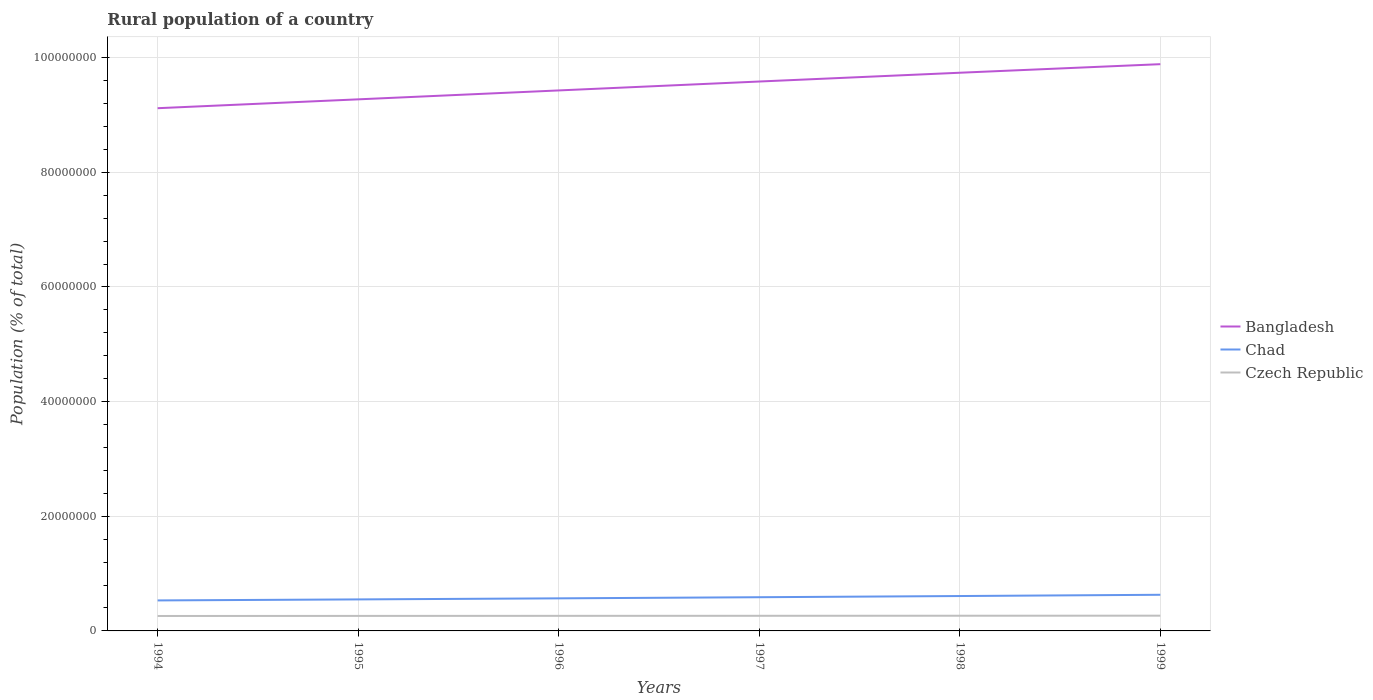Does the line corresponding to Czech Republic intersect with the line corresponding to Chad?
Keep it short and to the point. No. Is the number of lines equal to the number of legend labels?
Offer a very short reply. Yes. Across all years, what is the maximum rural population in Czech Republic?
Give a very brief answer. 2.61e+06. What is the total rural population in Bangladesh in the graph?
Give a very brief answer. -1.56e+06. What is the difference between the highest and the second highest rural population in Chad?
Your response must be concise. 9.84e+05. Is the rural population in Czech Republic strictly greater than the rural population in Bangladesh over the years?
Keep it short and to the point. Yes. How many lines are there?
Ensure brevity in your answer.  3. What is the difference between two consecutive major ticks on the Y-axis?
Offer a very short reply. 2.00e+07. Are the values on the major ticks of Y-axis written in scientific E-notation?
Make the answer very short. No. Does the graph contain any zero values?
Offer a very short reply. No. Does the graph contain grids?
Ensure brevity in your answer.  Yes. Where does the legend appear in the graph?
Offer a terse response. Center right. How are the legend labels stacked?
Keep it short and to the point. Vertical. What is the title of the graph?
Your answer should be very brief. Rural population of a country. What is the label or title of the Y-axis?
Keep it short and to the point. Population (% of total). What is the Population (% of total) in Bangladesh in 1994?
Offer a terse response. 9.12e+07. What is the Population (% of total) of Chad in 1994?
Your answer should be very brief. 5.32e+06. What is the Population (% of total) in Czech Republic in 1994?
Your answer should be compact. 2.61e+06. What is the Population (% of total) in Bangladesh in 1995?
Your response must be concise. 9.27e+07. What is the Population (% of total) of Chad in 1995?
Give a very brief answer. 5.50e+06. What is the Population (% of total) of Czech Republic in 1995?
Your answer should be very brief. 2.62e+06. What is the Population (% of total) in Bangladesh in 1996?
Ensure brevity in your answer.  9.43e+07. What is the Population (% of total) of Chad in 1996?
Offer a very short reply. 5.68e+06. What is the Population (% of total) of Czech Republic in 1996?
Provide a short and direct response. 2.63e+06. What is the Population (% of total) in Bangladesh in 1997?
Ensure brevity in your answer.  9.58e+07. What is the Population (% of total) of Chad in 1997?
Offer a very short reply. 5.88e+06. What is the Population (% of total) of Czech Republic in 1997?
Your answer should be very brief. 2.64e+06. What is the Population (% of total) of Bangladesh in 1998?
Keep it short and to the point. 9.74e+07. What is the Population (% of total) in Chad in 1998?
Provide a short and direct response. 6.09e+06. What is the Population (% of total) of Czech Republic in 1998?
Your response must be concise. 2.65e+06. What is the Population (% of total) in Bangladesh in 1999?
Your answer should be very brief. 9.89e+07. What is the Population (% of total) in Chad in 1999?
Give a very brief answer. 6.31e+06. What is the Population (% of total) in Czech Republic in 1999?
Your answer should be very brief. 2.66e+06. Across all years, what is the maximum Population (% of total) in Bangladesh?
Your response must be concise. 9.89e+07. Across all years, what is the maximum Population (% of total) of Chad?
Make the answer very short. 6.31e+06. Across all years, what is the maximum Population (% of total) in Czech Republic?
Your response must be concise. 2.66e+06. Across all years, what is the minimum Population (% of total) in Bangladesh?
Your answer should be compact. 9.12e+07. Across all years, what is the minimum Population (% of total) in Chad?
Offer a terse response. 5.32e+06. Across all years, what is the minimum Population (% of total) in Czech Republic?
Provide a short and direct response. 2.61e+06. What is the total Population (% of total) in Bangladesh in the graph?
Make the answer very short. 5.70e+08. What is the total Population (% of total) in Chad in the graph?
Offer a terse response. 3.48e+07. What is the total Population (% of total) in Czech Republic in the graph?
Your answer should be very brief. 1.58e+07. What is the difference between the Population (% of total) in Bangladesh in 1994 and that in 1995?
Offer a terse response. -1.55e+06. What is the difference between the Population (% of total) of Chad in 1994 and that in 1995?
Offer a very short reply. -1.77e+05. What is the difference between the Population (% of total) of Czech Republic in 1994 and that in 1995?
Offer a very short reply. -1.17e+04. What is the difference between the Population (% of total) in Bangladesh in 1994 and that in 1996?
Your answer should be compact. -3.10e+06. What is the difference between the Population (% of total) in Chad in 1994 and that in 1996?
Your response must be concise. -3.64e+05. What is the difference between the Population (% of total) in Czech Republic in 1994 and that in 1996?
Your answer should be very brief. -2.21e+04. What is the difference between the Population (% of total) of Bangladesh in 1994 and that in 1997?
Your answer should be compact. -4.65e+06. What is the difference between the Population (% of total) in Chad in 1994 and that in 1997?
Provide a short and direct response. -5.59e+05. What is the difference between the Population (% of total) of Czech Republic in 1994 and that in 1997?
Your answer should be compact. -3.28e+04. What is the difference between the Population (% of total) of Bangladesh in 1994 and that in 1998?
Ensure brevity in your answer.  -6.19e+06. What is the difference between the Population (% of total) of Chad in 1994 and that in 1998?
Keep it short and to the point. -7.65e+05. What is the difference between the Population (% of total) in Czech Republic in 1994 and that in 1998?
Ensure brevity in your answer.  -4.37e+04. What is the difference between the Population (% of total) of Bangladesh in 1994 and that in 1999?
Keep it short and to the point. -7.68e+06. What is the difference between the Population (% of total) in Chad in 1994 and that in 1999?
Your answer should be compact. -9.84e+05. What is the difference between the Population (% of total) of Czech Republic in 1994 and that in 1999?
Offer a terse response. -5.45e+04. What is the difference between the Population (% of total) in Bangladesh in 1995 and that in 1996?
Your answer should be compact. -1.56e+06. What is the difference between the Population (% of total) in Chad in 1995 and that in 1996?
Your response must be concise. -1.86e+05. What is the difference between the Population (% of total) in Czech Republic in 1995 and that in 1996?
Offer a terse response. -1.04e+04. What is the difference between the Population (% of total) in Bangladesh in 1995 and that in 1997?
Offer a very short reply. -3.11e+06. What is the difference between the Population (% of total) in Chad in 1995 and that in 1997?
Your answer should be compact. -3.82e+05. What is the difference between the Population (% of total) of Czech Republic in 1995 and that in 1997?
Keep it short and to the point. -2.10e+04. What is the difference between the Population (% of total) in Bangladesh in 1995 and that in 1998?
Ensure brevity in your answer.  -4.64e+06. What is the difference between the Population (% of total) in Chad in 1995 and that in 1998?
Ensure brevity in your answer.  -5.88e+05. What is the difference between the Population (% of total) of Czech Republic in 1995 and that in 1998?
Make the answer very short. -3.20e+04. What is the difference between the Population (% of total) in Bangladesh in 1995 and that in 1999?
Offer a very short reply. -6.14e+06. What is the difference between the Population (% of total) in Chad in 1995 and that in 1999?
Your answer should be very brief. -8.07e+05. What is the difference between the Population (% of total) in Czech Republic in 1995 and that in 1999?
Make the answer very short. -4.28e+04. What is the difference between the Population (% of total) in Bangladesh in 1996 and that in 1997?
Offer a very short reply. -1.55e+06. What is the difference between the Population (% of total) in Chad in 1996 and that in 1997?
Your response must be concise. -1.96e+05. What is the difference between the Population (% of total) of Czech Republic in 1996 and that in 1997?
Provide a succinct answer. -1.07e+04. What is the difference between the Population (% of total) of Bangladesh in 1996 and that in 1998?
Provide a succinct answer. -3.09e+06. What is the difference between the Population (% of total) of Chad in 1996 and that in 1998?
Your answer should be compact. -4.02e+05. What is the difference between the Population (% of total) in Czech Republic in 1996 and that in 1998?
Give a very brief answer. -2.17e+04. What is the difference between the Population (% of total) in Bangladesh in 1996 and that in 1999?
Provide a short and direct response. -4.58e+06. What is the difference between the Population (% of total) in Chad in 1996 and that in 1999?
Keep it short and to the point. -6.21e+05. What is the difference between the Population (% of total) in Czech Republic in 1996 and that in 1999?
Make the answer very short. -3.24e+04. What is the difference between the Population (% of total) in Bangladesh in 1997 and that in 1998?
Your answer should be compact. -1.53e+06. What is the difference between the Population (% of total) of Chad in 1997 and that in 1998?
Offer a terse response. -2.06e+05. What is the difference between the Population (% of total) of Czech Republic in 1997 and that in 1998?
Provide a succinct answer. -1.10e+04. What is the difference between the Population (% of total) of Bangladesh in 1997 and that in 1999?
Offer a terse response. -3.03e+06. What is the difference between the Population (% of total) in Chad in 1997 and that in 1999?
Provide a short and direct response. -4.25e+05. What is the difference between the Population (% of total) in Czech Republic in 1997 and that in 1999?
Your answer should be compact. -2.18e+04. What is the difference between the Population (% of total) of Bangladesh in 1998 and that in 1999?
Ensure brevity in your answer.  -1.49e+06. What is the difference between the Population (% of total) in Chad in 1998 and that in 1999?
Offer a very short reply. -2.19e+05. What is the difference between the Population (% of total) in Czech Republic in 1998 and that in 1999?
Offer a very short reply. -1.08e+04. What is the difference between the Population (% of total) in Bangladesh in 1994 and the Population (% of total) in Chad in 1995?
Offer a terse response. 8.57e+07. What is the difference between the Population (% of total) of Bangladesh in 1994 and the Population (% of total) of Czech Republic in 1995?
Give a very brief answer. 8.86e+07. What is the difference between the Population (% of total) in Chad in 1994 and the Population (% of total) in Czech Republic in 1995?
Make the answer very short. 2.70e+06. What is the difference between the Population (% of total) of Bangladesh in 1994 and the Population (% of total) of Chad in 1996?
Provide a short and direct response. 8.55e+07. What is the difference between the Population (% of total) of Bangladesh in 1994 and the Population (% of total) of Czech Republic in 1996?
Your answer should be very brief. 8.86e+07. What is the difference between the Population (% of total) of Chad in 1994 and the Population (% of total) of Czech Republic in 1996?
Provide a succinct answer. 2.69e+06. What is the difference between the Population (% of total) of Bangladesh in 1994 and the Population (% of total) of Chad in 1997?
Provide a short and direct response. 8.53e+07. What is the difference between the Population (% of total) of Bangladesh in 1994 and the Population (% of total) of Czech Republic in 1997?
Provide a short and direct response. 8.86e+07. What is the difference between the Population (% of total) in Chad in 1994 and the Population (% of total) in Czech Republic in 1997?
Your response must be concise. 2.68e+06. What is the difference between the Population (% of total) in Bangladesh in 1994 and the Population (% of total) in Chad in 1998?
Keep it short and to the point. 8.51e+07. What is the difference between the Population (% of total) of Bangladesh in 1994 and the Population (% of total) of Czech Republic in 1998?
Make the answer very short. 8.85e+07. What is the difference between the Population (% of total) in Chad in 1994 and the Population (% of total) in Czech Republic in 1998?
Make the answer very short. 2.67e+06. What is the difference between the Population (% of total) in Bangladesh in 1994 and the Population (% of total) in Chad in 1999?
Offer a terse response. 8.49e+07. What is the difference between the Population (% of total) in Bangladesh in 1994 and the Population (% of total) in Czech Republic in 1999?
Give a very brief answer. 8.85e+07. What is the difference between the Population (% of total) in Chad in 1994 and the Population (% of total) in Czech Republic in 1999?
Your answer should be very brief. 2.66e+06. What is the difference between the Population (% of total) of Bangladesh in 1995 and the Population (% of total) of Chad in 1996?
Your response must be concise. 8.71e+07. What is the difference between the Population (% of total) in Bangladesh in 1995 and the Population (% of total) in Czech Republic in 1996?
Keep it short and to the point. 9.01e+07. What is the difference between the Population (% of total) of Chad in 1995 and the Population (% of total) of Czech Republic in 1996?
Give a very brief answer. 2.87e+06. What is the difference between the Population (% of total) in Bangladesh in 1995 and the Population (% of total) in Chad in 1997?
Your answer should be very brief. 8.69e+07. What is the difference between the Population (% of total) in Bangladesh in 1995 and the Population (% of total) in Czech Republic in 1997?
Keep it short and to the point. 9.01e+07. What is the difference between the Population (% of total) in Chad in 1995 and the Population (% of total) in Czech Republic in 1997?
Give a very brief answer. 2.86e+06. What is the difference between the Population (% of total) in Bangladesh in 1995 and the Population (% of total) in Chad in 1998?
Provide a succinct answer. 8.67e+07. What is the difference between the Population (% of total) in Bangladesh in 1995 and the Population (% of total) in Czech Republic in 1998?
Provide a short and direct response. 9.01e+07. What is the difference between the Population (% of total) of Chad in 1995 and the Population (% of total) of Czech Republic in 1998?
Keep it short and to the point. 2.85e+06. What is the difference between the Population (% of total) of Bangladesh in 1995 and the Population (% of total) of Chad in 1999?
Your response must be concise. 8.64e+07. What is the difference between the Population (% of total) in Bangladesh in 1995 and the Population (% of total) in Czech Republic in 1999?
Keep it short and to the point. 9.01e+07. What is the difference between the Population (% of total) of Chad in 1995 and the Population (% of total) of Czech Republic in 1999?
Offer a terse response. 2.84e+06. What is the difference between the Population (% of total) in Bangladesh in 1996 and the Population (% of total) in Chad in 1997?
Keep it short and to the point. 8.84e+07. What is the difference between the Population (% of total) in Bangladesh in 1996 and the Population (% of total) in Czech Republic in 1997?
Offer a very short reply. 9.17e+07. What is the difference between the Population (% of total) in Chad in 1996 and the Population (% of total) in Czech Republic in 1997?
Your answer should be very brief. 3.04e+06. What is the difference between the Population (% of total) in Bangladesh in 1996 and the Population (% of total) in Chad in 1998?
Give a very brief answer. 8.82e+07. What is the difference between the Population (% of total) in Bangladesh in 1996 and the Population (% of total) in Czech Republic in 1998?
Make the answer very short. 9.16e+07. What is the difference between the Population (% of total) in Chad in 1996 and the Population (% of total) in Czech Republic in 1998?
Offer a terse response. 3.03e+06. What is the difference between the Population (% of total) in Bangladesh in 1996 and the Population (% of total) in Chad in 1999?
Your response must be concise. 8.80e+07. What is the difference between the Population (% of total) of Bangladesh in 1996 and the Population (% of total) of Czech Republic in 1999?
Offer a terse response. 9.16e+07. What is the difference between the Population (% of total) of Chad in 1996 and the Population (% of total) of Czech Republic in 1999?
Make the answer very short. 3.02e+06. What is the difference between the Population (% of total) in Bangladesh in 1997 and the Population (% of total) in Chad in 1998?
Your answer should be compact. 8.98e+07. What is the difference between the Population (% of total) of Bangladesh in 1997 and the Population (% of total) of Czech Republic in 1998?
Your answer should be very brief. 9.32e+07. What is the difference between the Population (% of total) in Chad in 1997 and the Population (% of total) in Czech Republic in 1998?
Keep it short and to the point. 3.23e+06. What is the difference between the Population (% of total) of Bangladesh in 1997 and the Population (% of total) of Chad in 1999?
Offer a very short reply. 8.95e+07. What is the difference between the Population (% of total) of Bangladesh in 1997 and the Population (% of total) of Czech Republic in 1999?
Your response must be concise. 9.32e+07. What is the difference between the Population (% of total) of Chad in 1997 and the Population (% of total) of Czech Republic in 1999?
Ensure brevity in your answer.  3.22e+06. What is the difference between the Population (% of total) in Bangladesh in 1998 and the Population (% of total) in Chad in 1999?
Keep it short and to the point. 9.11e+07. What is the difference between the Population (% of total) in Bangladesh in 1998 and the Population (% of total) in Czech Republic in 1999?
Ensure brevity in your answer.  9.47e+07. What is the difference between the Population (% of total) in Chad in 1998 and the Population (% of total) in Czech Republic in 1999?
Give a very brief answer. 3.42e+06. What is the average Population (% of total) in Bangladesh per year?
Ensure brevity in your answer.  9.51e+07. What is the average Population (% of total) of Chad per year?
Provide a short and direct response. 5.80e+06. What is the average Population (% of total) in Czech Republic per year?
Your answer should be very brief. 2.63e+06. In the year 1994, what is the difference between the Population (% of total) in Bangladesh and Population (% of total) in Chad?
Provide a succinct answer. 8.59e+07. In the year 1994, what is the difference between the Population (% of total) in Bangladesh and Population (% of total) in Czech Republic?
Ensure brevity in your answer.  8.86e+07. In the year 1994, what is the difference between the Population (% of total) of Chad and Population (% of total) of Czech Republic?
Your answer should be very brief. 2.71e+06. In the year 1995, what is the difference between the Population (% of total) of Bangladesh and Population (% of total) of Chad?
Keep it short and to the point. 8.72e+07. In the year 1995, what is the difference between the Population (% of total) in Bangladesh and Population (% of total) in Czech Republic?
Offer a terse response. 9.01e+07. In the year 1995, what is the difference between the Population (% of total) in Chad and Population (% of total) in Czech Republic?
Your answer should be compact. 2.88e+06. In the year 1996, what is the difference between the Population (% of total) of Bangladesh and Population (% of total) of Chad?
Offer a terse response. 8.86e+07. In the year 1996, what is the difference between the Population (% of total) in Bangladesh and Population (% of total) in Czech Republic?
Make the answer very short. 9.17e+07. In the year 1996, what is the difference between the Population (% of total) in Chad and Population (% of total) in Czech Republic?
Ensure brevity in your answer.  3.06e+06. In the year 1997, what is the difference between the Population (% of total) of Bangladesh and Population (% of total) of Chad?
Offer a very short reply. 9.00e+07. In the year 1997, what is the difference between the Population (% of total) of Bangladesh and Population (% of total) of Czech Republic?
Offer a very short reply. 9.32e+07. In the year 1997, what is the difference between the Population (% of total) in Chad and Population (% of total) in Czech Republic?
Offer a terse response. 3.24e+06. In the year 1998, what is the difference between the Population (% of total) of Bangladesh and Population (% of total) of Chad?
Your answer should be very brief. 9.13e+07. In the year 1998, what is the difference between the Population (% of total) in Bangladesh and Population (% of total) in Czech Republic?
Provide a short and direct response. 9.47e+07. In the year 1998, what is the difference between the Population (% of total) of Chad and Population (% of total) of Czech Republic?
Ensure brevity in your answer.  3.44e+06. In the year 1999, what is the difference between the Population (% of total) in Bangladesh and Population (% of total) in Chad?
Your answer should be very brief. 9.26e+07. In the year 1999, what is the difference between the Population (% of total) in Bangladesh and Population (% of total) in Czech Republic?
Provide a succinct answer. 9.62e+07. In the year 1999, what is the difference between the Population (% of total) of Chad and Population (% of total) of Czech Republic?
Make the answer very short. 3.64e+06. What is the ratio of the Population (% of total) of Bangladesh in 1994 to that in 1995?
Your response must be concise. 0.98. What is the ratio of the Population (% of total) in Chad in 1994 to that in 1995?
Keep it short and to the point. 0.97. What is the ratio of the Population (% of total) of Czech Republic in 1994 to that in 1995?
Offer a terse response. 1. What is the ratio of the Population (% of total) in Bangladesh in 1994 to that in 1996?
Your answer should be compact. 0.97. What is the ratio of the Population (% of total) in Chad in 1994 to that in 1996?
Your answer should be very brief. 0.94. What is the ratio of the Population (% of total) in Czech Republic in 1994 to that in 1996?
Give a very brief answer. 0.99. What is the ratio of the Population (% of total) of Bangladesh in 1994 to that in 1997?
Keep it short and to the point. 0.95. What is the ratio of the Population (% of total) of Chad in 1994 to that in 1997?
Your answer should be compact. 0.9. What is the ratio of the Population (% of total) in Czech Republic in 1994 to that in 1997?
Provide a succinct answer. 0.99. What is the ratio of the Population (% of total) of Bangladesh in 1994 to that in 1998?
Your answer should be very brief. 0.94. What is the ratio of the Population (% of total) in Chad in 1994 to that in 1998?
Ensure brevity in your answer.  0.87. What is the ratio of the Population (% of total) of Czech Republic in 1994 to that in 1998?
Your answer should be compact. 0.98. What is the ratio of the Population (% of total) of Bangladesh in 1994 to that in 1999?
Your response must be concise. 0.92. What is the ratio of the Population (% of total) of Chad in 1994 to that in 1999?
Provide a succinct answer. 0.84. What is the ratio of the Population (% of total) in Czech Republic in 1994 to that in 1999?
Ensure brevity in your answer.  0.98. What is the ratio of the Population (% of total) in Bangladesh in 1995 to that in 1996?
Offer a terse response. 0.98. What is the ratio of the Population (% of total) in Chad in 1995 to that in 1996?
Your answer should be very brief. 0.97. What is the ratio of the Population (% of total) of Czech Republic in 1995 to that in 1996?
Provide a succinct answer. 1. What is the ratio of the Population (% of total) of Bangladesh in 1995 to that in 1997?
Offer a very short reply. 0.97. What is the ratio of the Population (% of total) of Chad in 1995 to that in 1997?
Provide a succinct answer. 0.94. What is the ratio of the Population (% of total) in Bangladesh in 1995 to that in 1998?
Your response must be concise. 0.95. What is the ratio of the Population (% of total) of Chad in 1995 to that in 1998?
Provide a succinct answer. 0.9. What is the ratio of the Population (% of total) in Czech Republic in 1995 to that in 1998?
Provide a short and direct response. 0.99. What is the ratio of the Population (% of total) of Bangladesh in 1995 to that in 1999?
Give a very brief answer. 0.94. What is the ratio of the Population (% of total) in Chad in 1995 to that in 1999?
Keep it short and to the point. 0.87. What is the ratio of the Population (% of total) in Czech Republic in 1995 to that in 1999?
Provide a short and direct response. 0.98. What is the ratio of the Population (% of total) of Bangladesh in 1996 to that in 1997?
Provide a succinct answer. 0.98. What is the ratio of the Population (% of total) of Chad in 1996 to that in 1997?
Your answer should be compact. 0.97. What is the ratio of the Population (% of total) in Bangladesh in 1996 to that in 1998?
Provide a short and direct response. 0.97. What is the ratio of the Population (% of total) of Chad in 1996 to that in 1998?
Offer a terse response. 0.93. What is the ratio of the Population (% of total) of Czech Republic in 1996 to that in 1998?
Make the answer very short. 0.99. What is the ratio of the Population (% of total) of Bangladesh in 1996 to that in 1999?
Your answer should be very brief. 0.95. What is the ratio of the Population (% of total) of Chad in 1996 to that in 1999?
Your answer should be very brief. 0.9. What is the ratio of the Population (% of total) in Czech Republic in 1996 to that in 1999?
Your answer should be very brief. 0.99. What is the ratio of the Population (% of total) in Bangladesh in 1997 to that in 1998?
Ensure brevity in your answer.  0.98. What is the ratio of the Population (% of total) in Chad in 1997 to that in 1998?
Make the answer very short. 0.97. What is the ratio of the Population (% of total) of Bangladesh in 1997 to that in 1999?
Offer a very short reply. 0.97. What is the ratio of the Population (% of total) of Chad in 1997 to that in 1999?
Make the answer very short. 0.93. What is the ratio of the Population (% of total) of Bangladesh in 1998 to that in 1999?
Your response must be concise. 0.98. What is the ratio of the Population (% of total) of Chad in 1998 to that in 1999?
Keep it short and to the point. 0.97. What is the difference between the highest and the second highest Population (% of total) of Bangladesh?
Offer a terse response. 1.49e+06. What is the difference between the highest and the second highest Population (% of total) of Chad?
Make the answer very short. 2.19e+05. What is the difference between the highest and the second highest Population (% of total) of Czech Republic?
Provide a succinct answer. 1.08e+04. What is the difference between the highest and the lowest Population (% of total) of Bangladesh?
Keep it short and to the point. 7.68e+06. What is the difference between the highest and the lowest Population (% of total) in Chad?
Give a very brief answer. 9.84e+05. What is the difference between the highest and the lowest Population (% of total) of Czech Republic?
Make the answer very short. 5.45e+04. 